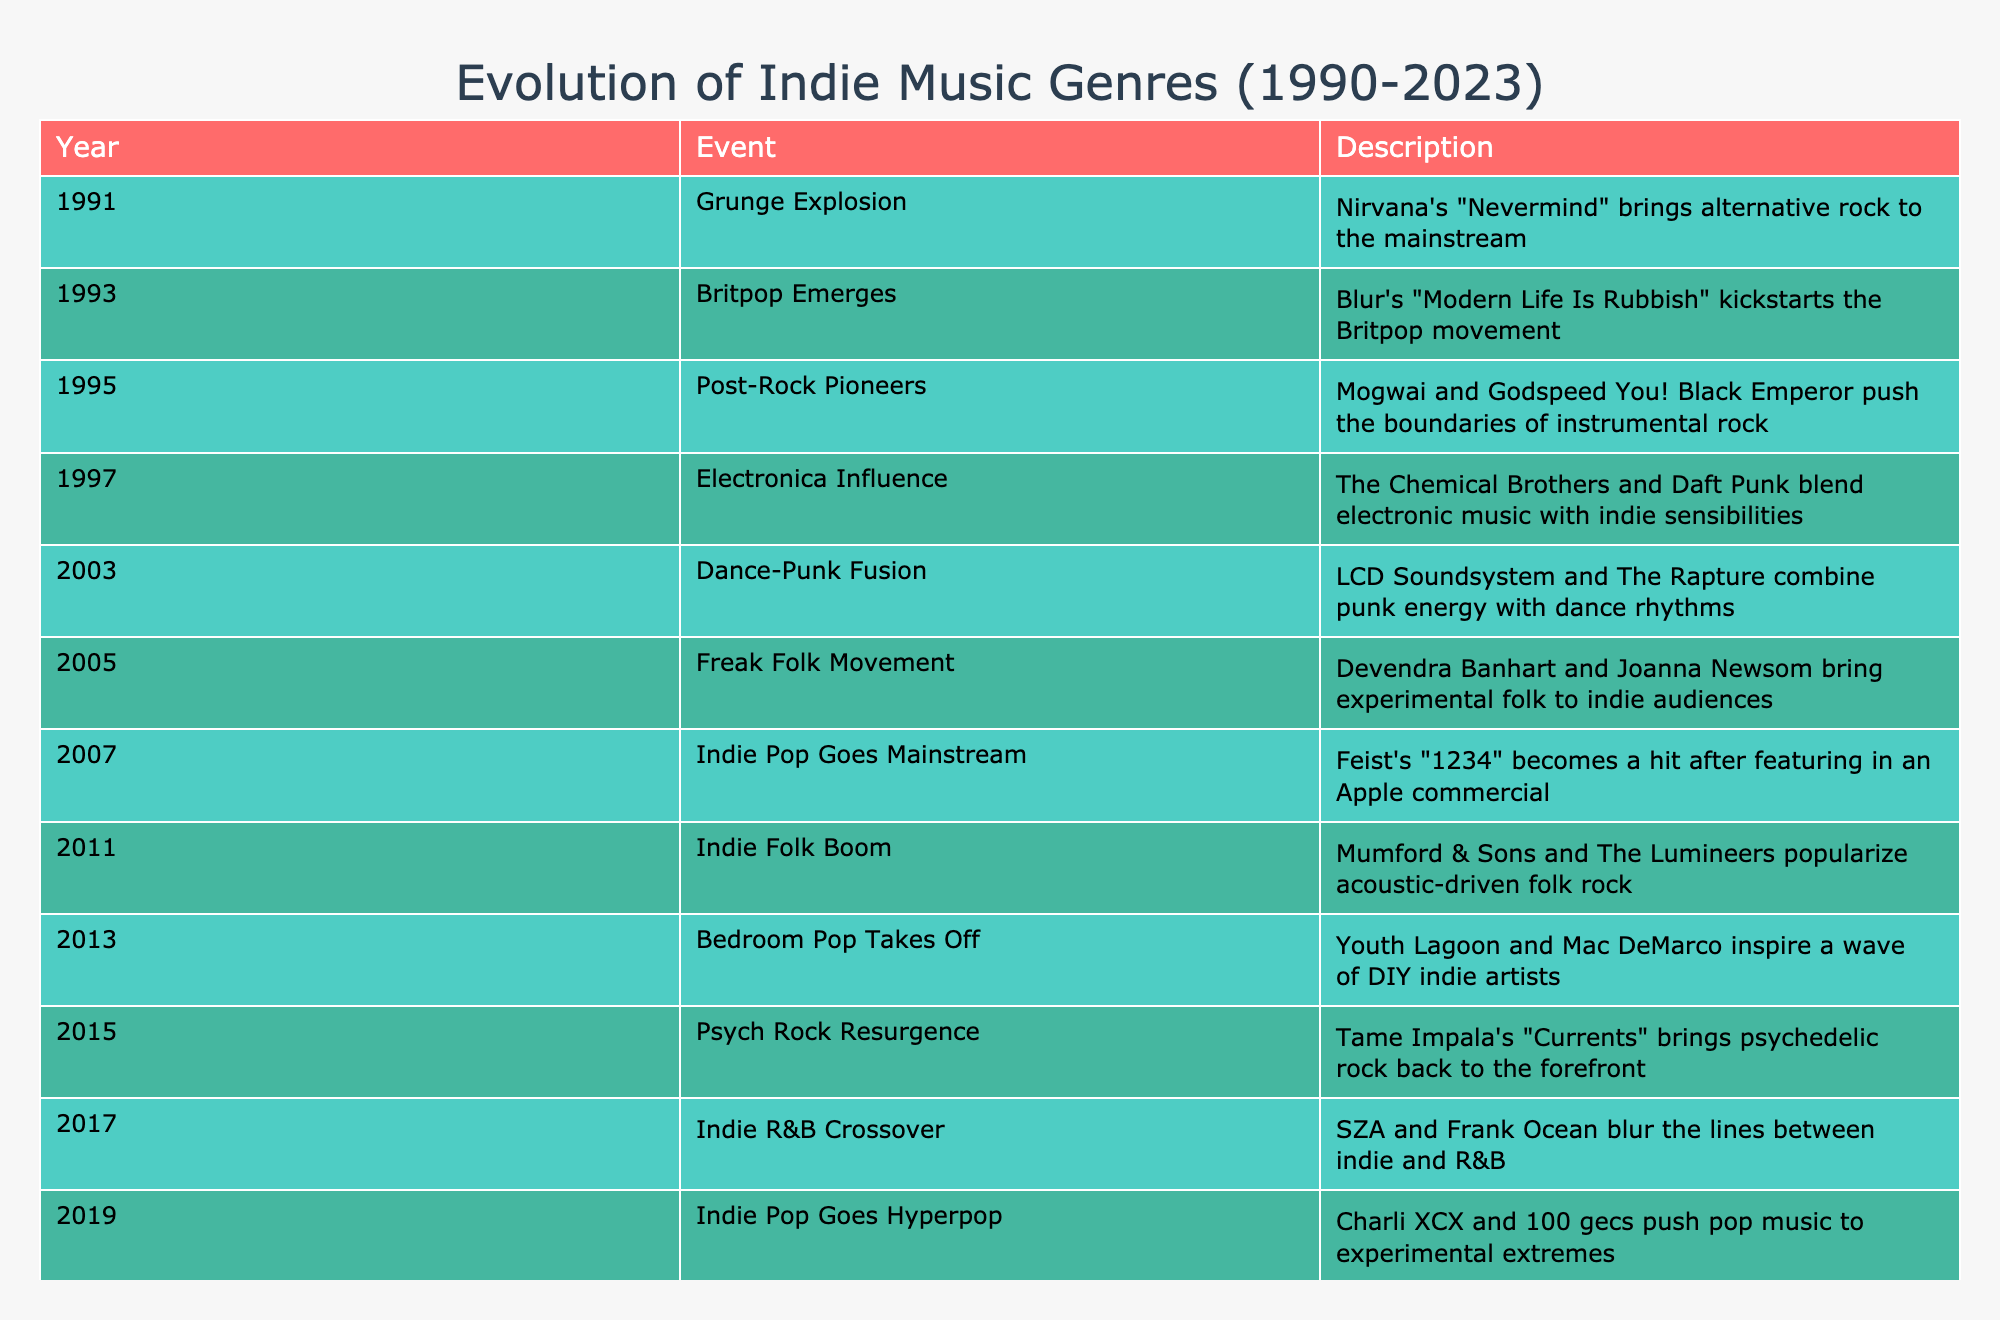What year did the Grunge explosion occur? The table lists the year for each event. Looking at the first row, the event "Grunge Explosion" happened in 1991.
Answer: 1991 Which artist's work marked the beginning of Britpop? According to the table, the event describing the emergence of Britpop states that Blur's "Modern Life Is Rubbish" kickstarted the movement in 1993.
Answer: Blur How many years apart were the Electronica Influence and Dance-Punk Fusion events? The Electronica Influence occurred in 1997 and Dance-Punk Fusion in 2003. Calculating the difference gives us 2003 - 1997 = 6 years.
Answer: 6 years Did the Indie Pop genre achieve mainstream success before or after 2005? By examining the table, we see that Indie Pop Goes Mainstream is listed under 2007, which is after 2005.
Answer: After Which event occurred in the year 2011, and what genre was it associated with? Looking at the table, the event in 2011 is "Indie Folk Boom," which is associated with indie folk music, as seen in the description of popularizing acoustic-driven folk rock.
Answer: Indie Folk Boom What is the trend in indie music genres based on the years 2011 to 2021? Between 2011 and 2021, we can observe a shift from Indie Folk Boom in 2011, to political themes in Indie Rock getting addressed in 2021, indicating a maturation of indie music with a social consciousness.
Answer: Social consciousness What were the two genres noted in 2017 and what is their relationship? The 2017 entry notes "Indie R&B Crossover" by SZA and Frank Ocean, indicating that both artists blended indie music with R&B, suggesting a crossover genre that merges distinct elements from both styles.
Answer: Indie and R&B Calculate how many distinct musical movements or genres were recognized from 1991 to 2023. The events listed from 1991 to 2023 total 13 distinct movements or genres in indie music, per the entries in the table.
Answer: 13 distinct movements 